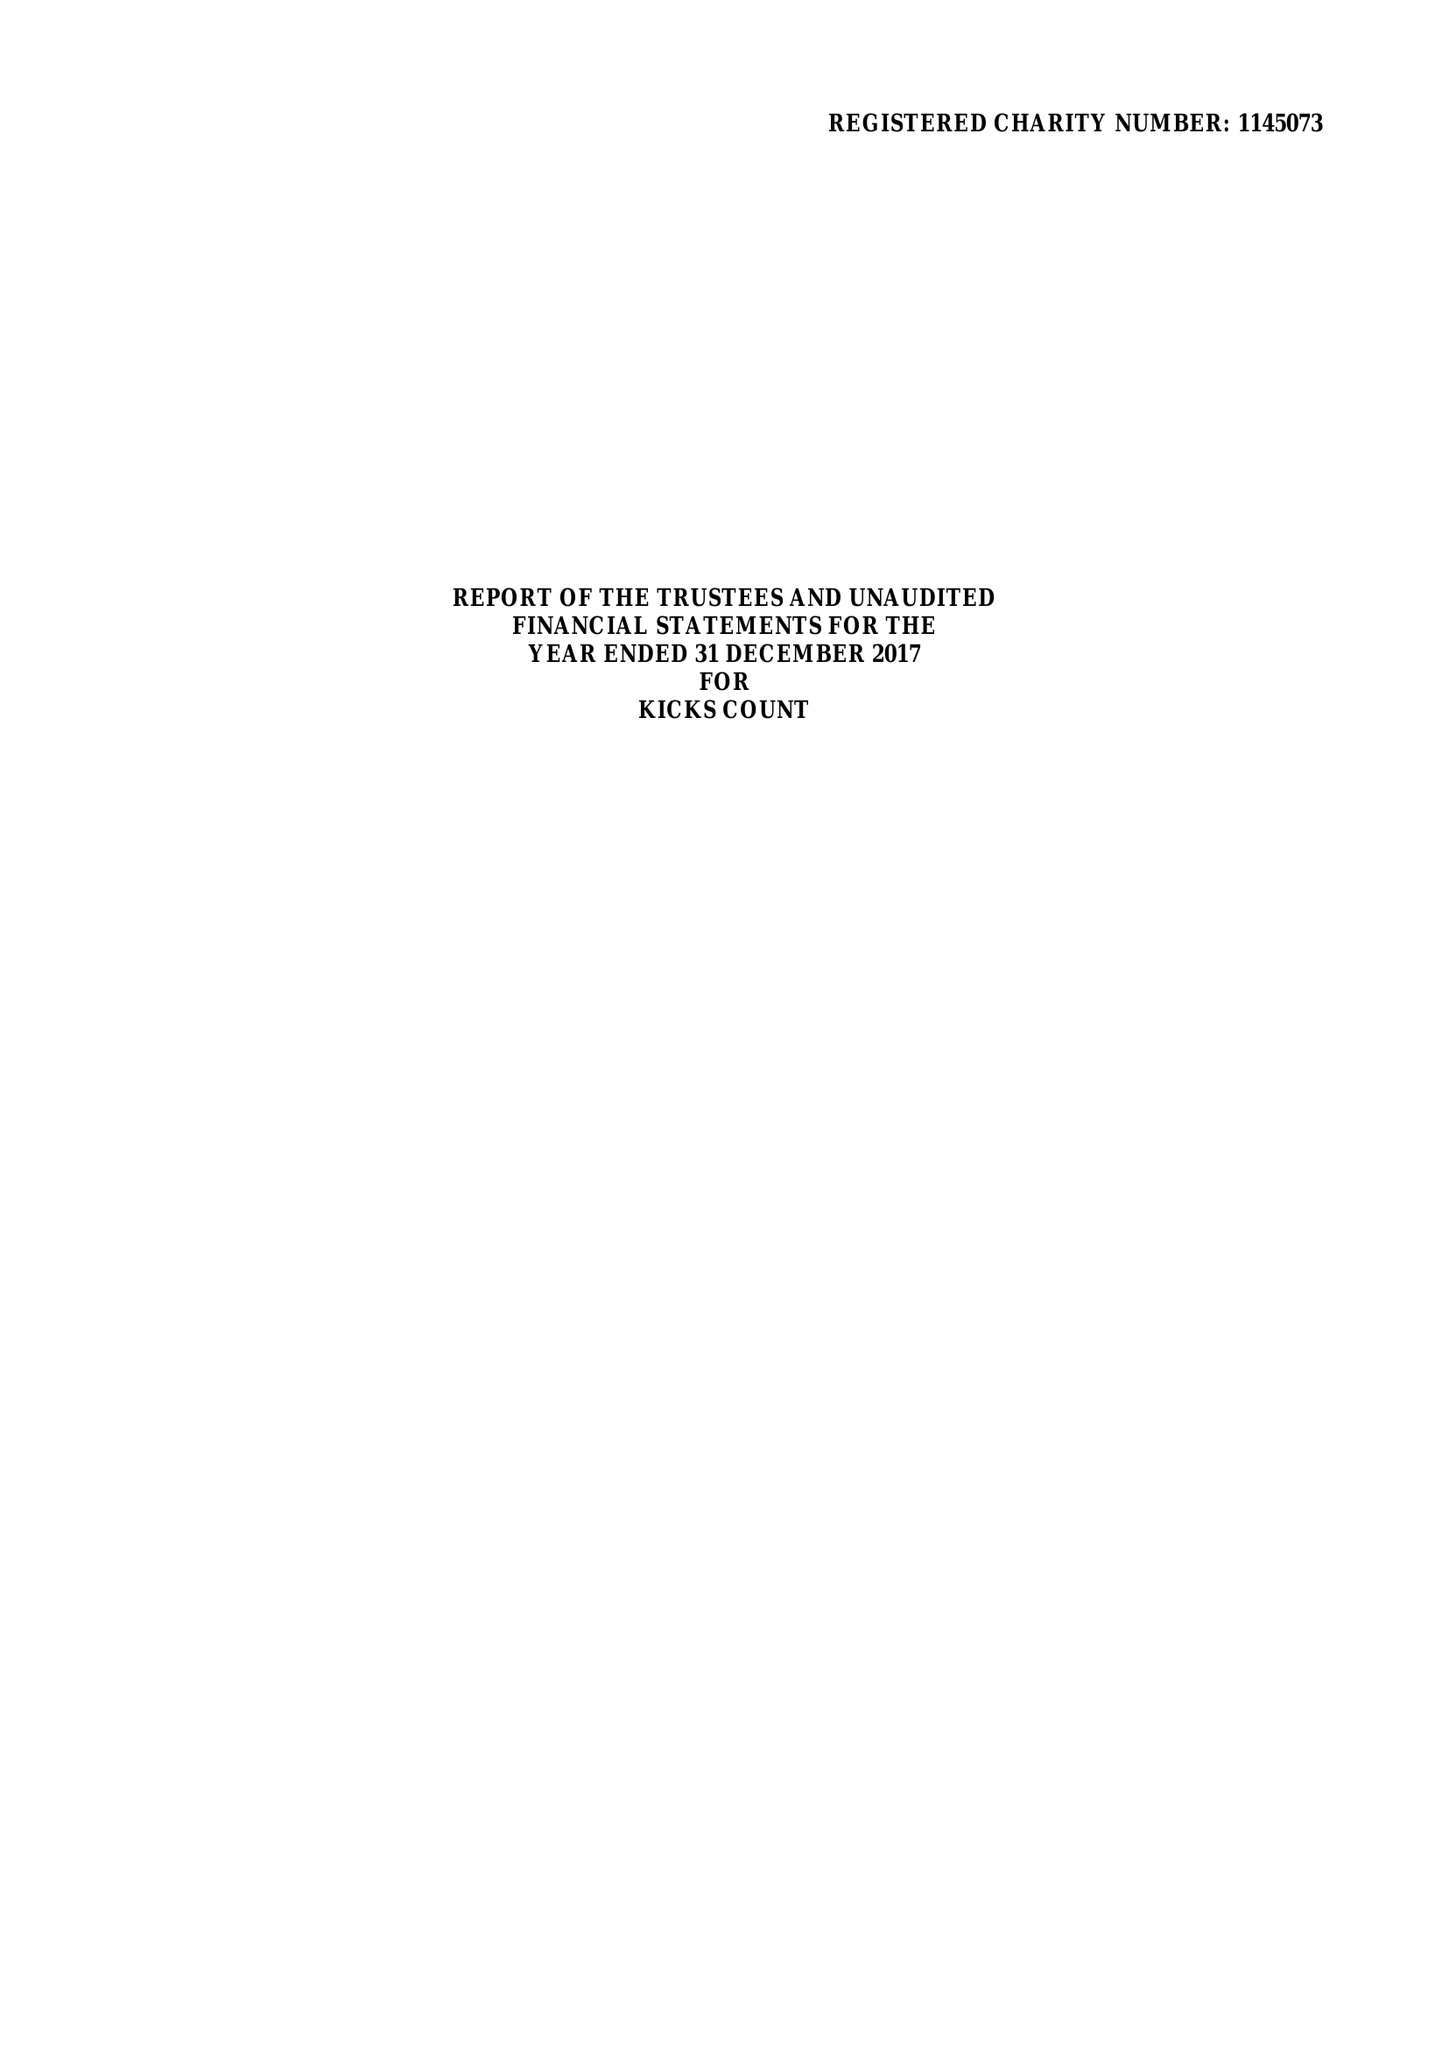What is the value for the address__street_line?
Answer the question using a single word or phrase. 10 THE COPSE 